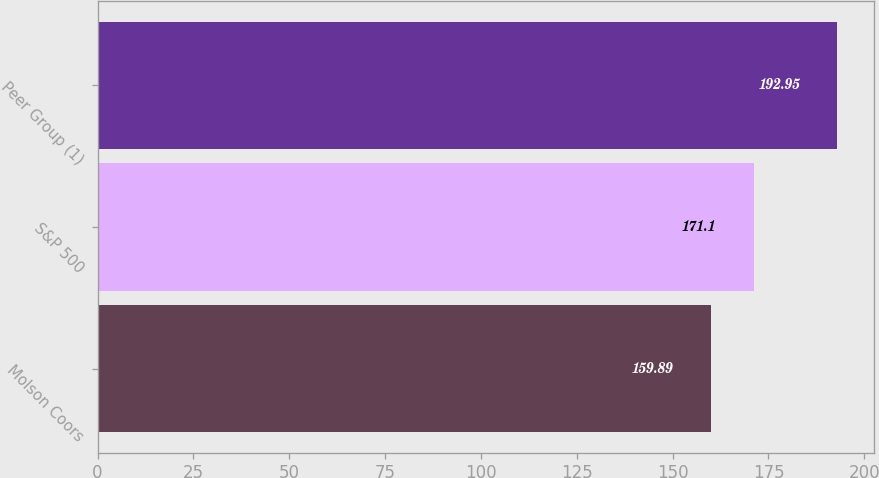Convert chart. <chart><loc_0><loc_0><loc_500><loc_500><bar_chart><fcel>Molson Coors<fcel>S&P 500<fcel>Peer Group (1)<nl><fcel>159.89<fcel>171.1<fcel>192.95<nl></chart> 